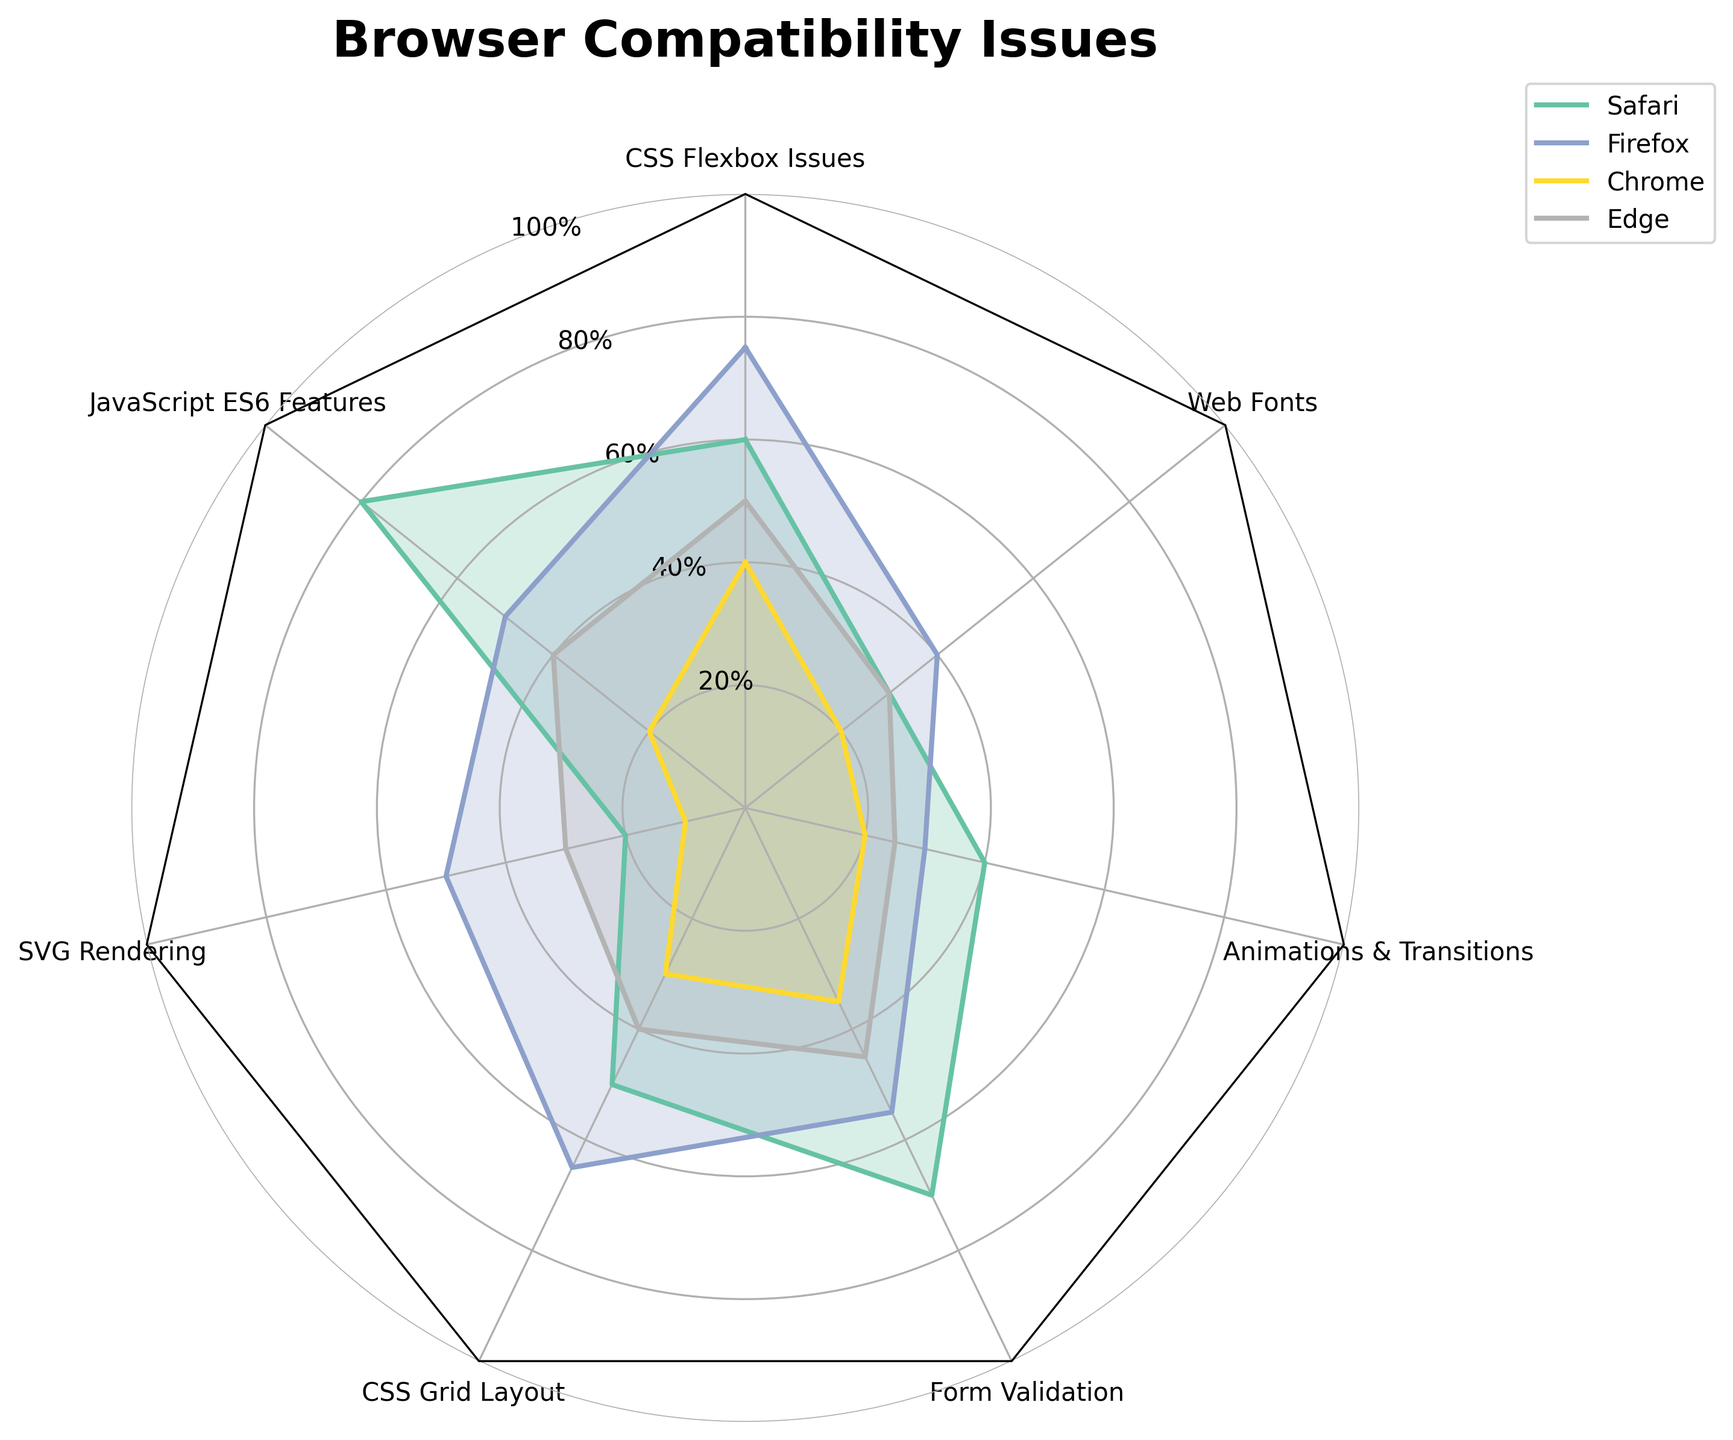What is the title of the figure? The title of the figure is usually the text at the top of the plot that summarizes what the chart is about. In the given plot, the title is clearly shown above the radar chart.
Answer: Browser Compatibility Issues Which browser has the highest severity for Form Validation issues? Examine the radar chart and look at the Form Validation issue. Identify the browser line that extends furthest from the center, which represents the highest severity.
Answer: Safari What is the overall impact on user experience for JavaScript ES6 Features compared to CSS Grid Layout? Both issues need to be examined in terms of their general scoring on the radar chart. JavaScript ES6 Features are generally marked higher than CSS Grid Layout, indicating a higher impact on user experience.
Answer: Higher Which issue is least problematic across all browsers? To find the least problematic issue, identify the segment that is closest to the center for all browsers. The segment with the smallest values across all browser lines indicates the least problematic issue.
Answer: SVG Rendering What are the average frequency percentages across all browsers for CSS Flexbox Issues? First, sum the frequencies of CSS Flexbox Issues for all browsers: 60 (Safari) + 75 (Firefox) + 40 (Chrome) + 50 (Edge). Then, divide by the number of browsers to find the average.
Answer: 56.25 Which browser shows the most consistent compatibility across different issues? Consistency is indicated by the smoothness and minimal spread of the browser's line in the radar chart. The line closest to a regular, balanced shape across all segments indicates the most consistent compatibility. Based on visual inspection, Edge appears most balanced.
Answer: Edge Identify the two issues with the highest frequency for any browser. By looking at the radar chart, except individual segments for each browser, CSS Flexbox Issues and Form Validation both extend significantly, indicating they have the highest frequencies among the browsers.
Answer: CSS Flexbox Issues, Form Validation Which two browsers have the closest severity levels for Web Fonts issues? Observe and compare the lengths of the segments for Web Fonts for all browsers. The two browsers whose segments are closest in length (value) are Safari and Edge.
Answer: Safari, Edge How many issues have a moderate impact on user experience? Refer to the data to count the issues categorized as having a moderate impact on user experience. CSS Flexbox, CSS Grid, and Web Fonts fall into this category.
Answer: 3 